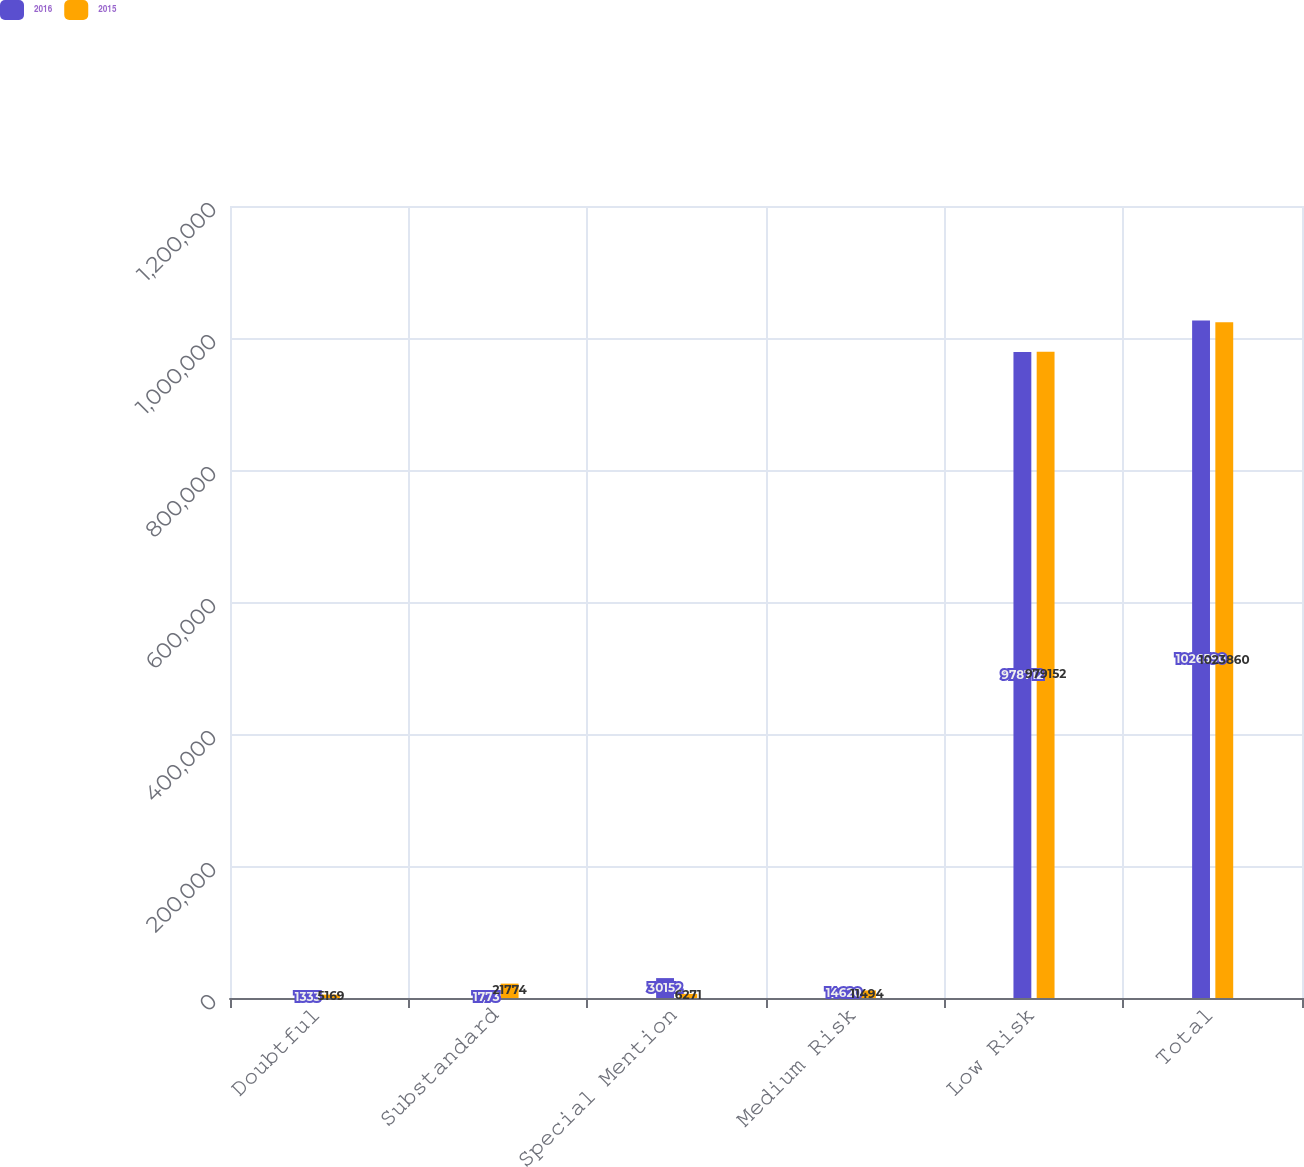Convert chart to OTSL. <chart><loc_0><loc_0><loc_500><loc_500><stacked_bar_chart><ecel><fcel>Doubtful<fcel>Substandard<fcel>Special Mention<fcel>Medium Risk<fcel>Low Risk<fcel>Total<nl><fcel>2016<fcel>1333<fcel>1773<fcel>30152<fcel>14620<fcel>978712<fcel>1.02659e+06<nl><fcel>2015<fcel>5169<fcel>21774<fcel>6271<fcel>11494<fcel>979152<fcel>1.02386e+06<nl></chart> 